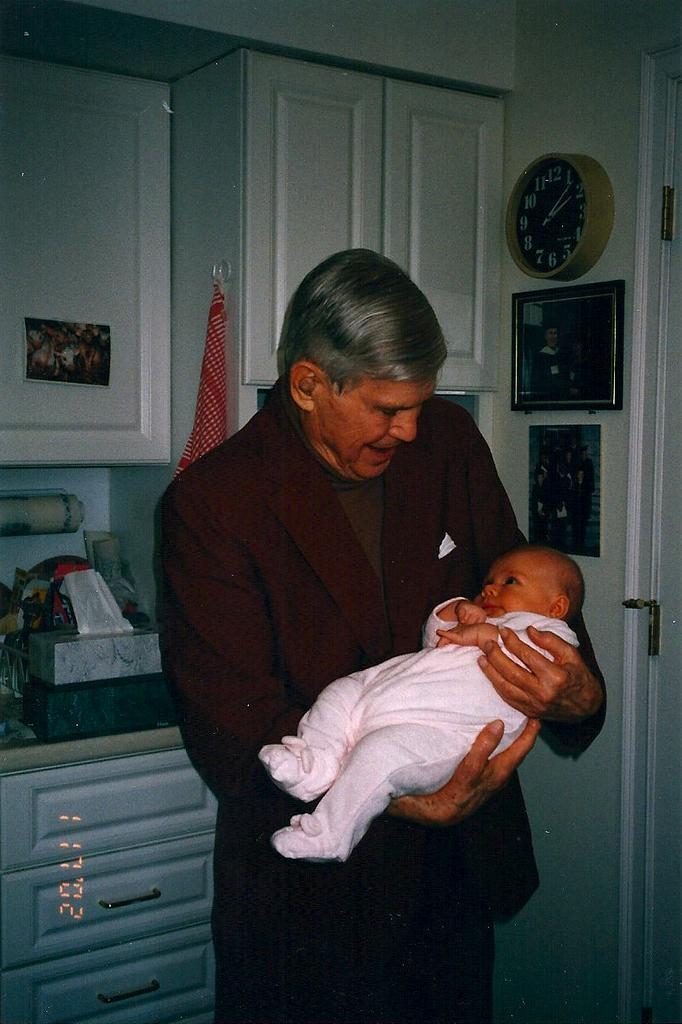Please provide a concise description of this image. In the center of the picture there is a person in red suit, holding a baby. On the right there are frame, clock, poster and door. On the left there are closet, drawer and other objects. In the background there are kerchief and closet. 